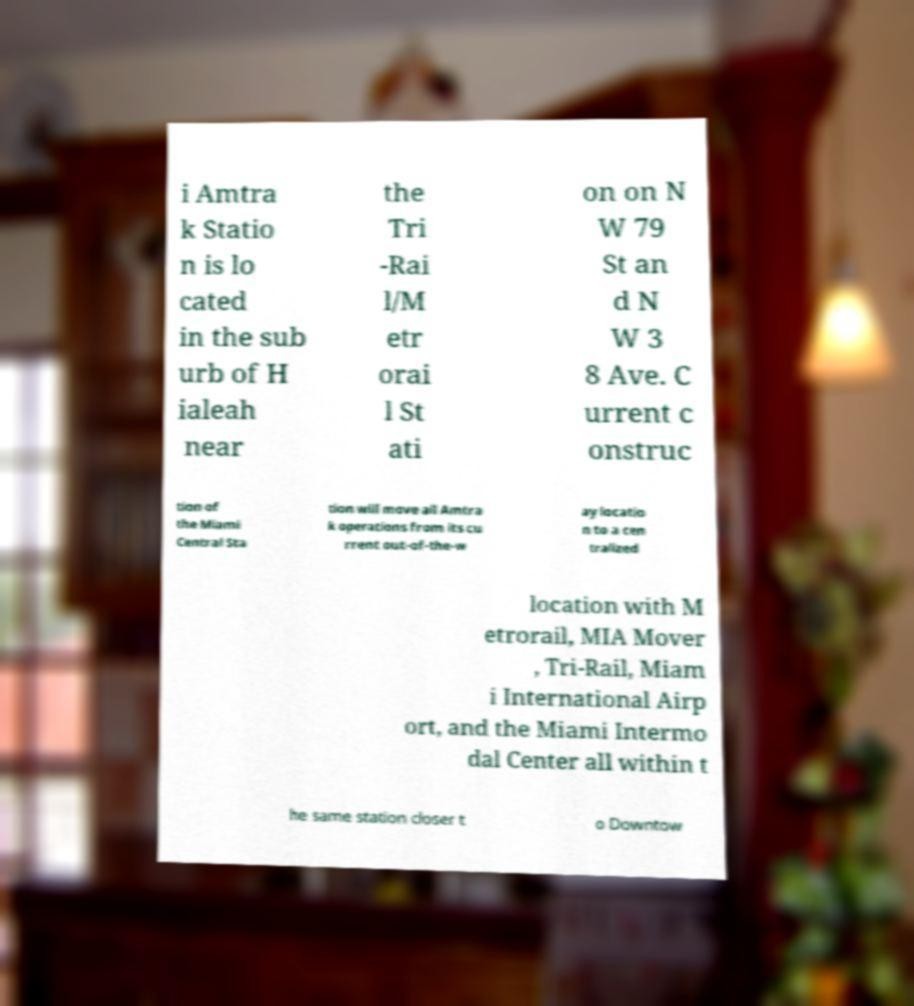Can you read and provide the text displayed in the image?This photo seems to have some interesting text. Can you extract and type it out for me? i Amtra k Statio n is lo cated in the sub urb of H ialeah near the Tri -Rai l/M etr orai l St ati on on N W 79 St an d N W 3 8 Ave. C urrent c onstruc tion of the Miami Central Sta tion will move all Amtra k operations from its cu rrent out-of-the-w ay locatio n to a cen tralized location with M etrorail, MIA Mover , Tri-Rail, Miam i International Airp ort, and the Miami Intermo dal Center all within t he same station closer t o Downtow 